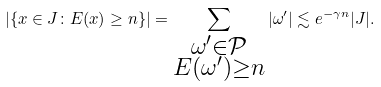Convert formula to latex. <formula><loc_0><loc_0><loc_500><loc_500>| \{ x \in J \colon E ( x ) \geq n \} | = \sum _ { \substack { \omega ^ { \prime } \in \mathcal { P } \\ E ( \omega ^ { \prime } ) \geq n } } | \omega ^ { \prime } | \lesssim e ^ { - \gamma n } | J | .</formula> 